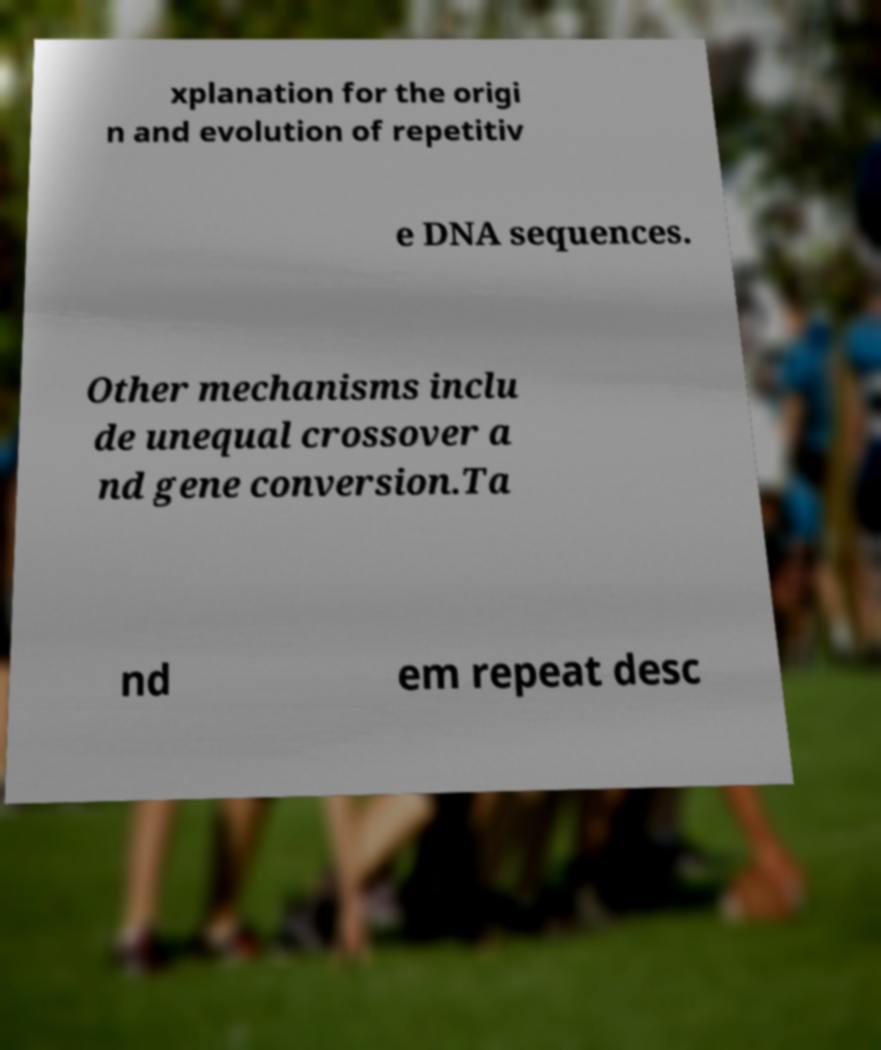Could you extract and type out the text from this image? xplanation for the origi n and evolution of repetitiv e DNA sequences. Other mechanisms inclu de unequal crossover a nd gene conversion.Ta nd em repeat desc 